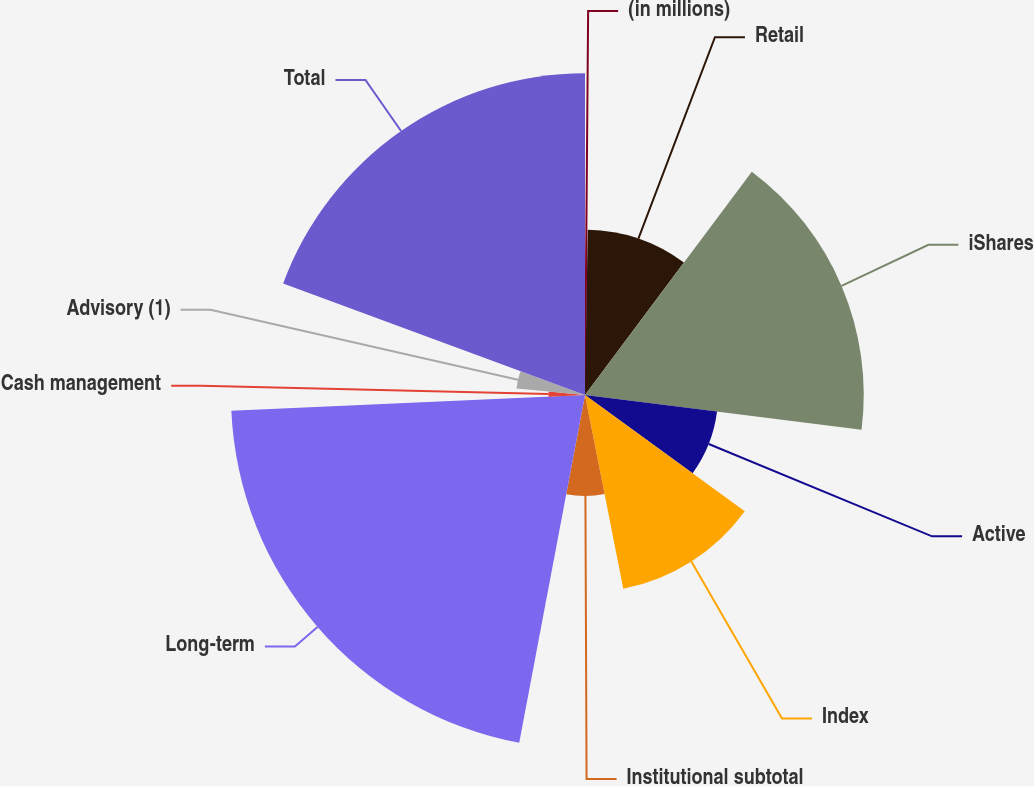Convert chart. <chart><loc_0><loc_0><loc_500><loc_500><pie_chart><fcel>(in millions)<fcel>Retail<fcel>iShares<fcel>Active<fcel>Index<fcel>Institutional subtotal<fcel>Long-term<fcel>Cash management<fcel>Advisory (1)<fcel>Total<nl><fcel>0.26%<fcel>9.95%<fcel>16.78%<fcel>8.01%<fcel>11.89%<fcel>6.08%<fcel>21.31%<fcel>2.2%<fcel>4.14%<fcel>19.37%<nl></chart> 